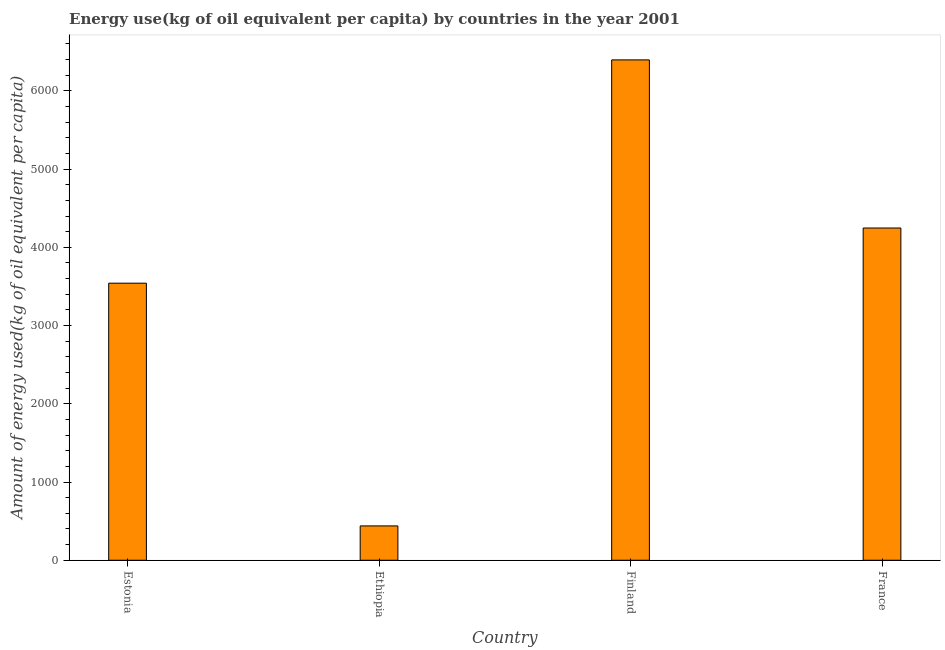Does the graph contain grids?
Your response must be concise. No. What is the title of the graph?
Offer a terse response. Energy use(kg of oil equivalent per capita) by countries in the year 2001. What is the label or title of the Y-axis?
Your answer should be compact. Amount of energy used(kg of oil equivalent per capita). What is the amount of energy used in Ethiopia?
Make the answer very short. 438.96. Across all countries, what is the maximum amount of energy used?
Your response must be concise. 6395.27. Across all countries, what is the minimum amount of energy used?
Give a very brief answer. 438.96. In which country was the amount of energy used minimum?
Make the answer very short. Ethiopia. What is the sum of the amount of energy used?
Provide a succinct answer. 1.46e+04. What is the difference between the amount of energy used in Ethiopia and Finland?
Offer a terse response. -5956.32. What is the average amount of energy used per country?
Keep it short and to the point. 3655.57. What is the median amount of energy used?
Make the answer very short. 3894.02. What is the ratio of the amount of energy used in Estonia to that in France?
Your response must be concise. 0.83. Is the difference between the amount of energy used in Estonia and Finland greater than the difference between any two countries?
Your answer should be very brief. No. What is the difference between the highest and the second highest amount of energy used?
Your response must be concise. 2148.76. Is the sum of the amount of energy used in Ethiopia and France greater than the maximum amount of energy used across all countries?
Your answer should be very brief. No. What is the difference between the highest and the lowest amount of energy used?
Offer a very short reply. 5956.32. How many bars are there?
Give a very brief answer. 4. Are all the bars in the graph horizontal?
Make the answer very short. No. What is the Amount of energy used(kg of oil equivalent per capita) of Estonia?
Your answer should be very brief. 3541.51. What is the Amount of energy used(kg of oil equivalent per capita) of Ethiopia?
Keep it short and to the point. 438.96. What is the Amount of energy used(kg of oil equivalent per capita) of Finland?
Give a very brief answer. 6395.27. What is the Amount of energy used(kg of oil equivalent per capita) of France?
Offer a terse response. 4246.52. What is the difference between the Amount of energy used(kg of oil equivalent per capita) in Estonia and Ethiopia?
Ensure brevity in your answer.  3102.55. What is the difference between the Amount of energy used(kg of oil equivalent per capita) in Estonia and Finland?
Make the answer very short. -2853.76. What is the difference between the Amount of energy used(kg of oil equivalent per capita) in Estonia and France?
Offer a very short reply. -705.01. What is the difference between the Amount of energy used(kg of oil equivalent per capita) in Ethiopia and Finland?
Offer a very short reply. -5956.32. What is the difference between the Amount of energy used(kg of oil equivalent per capita) in Ethiopia and France?
Provide a short and direct response. -3807.56. What is the difference between the Amount of energy used(kg of oil equivalent per capita) in Finland and France?
Your answer should be very brief. 2148.76. What is the ratio of the Amount of energy used(kg of oil equivalent per capita) in Estonia to that in Ethiopia?
Make the answer very short. 8.07. What is the ratio of the Amount of energy used(kg of oil equivalent per capita) in Estonia to that in Finland?
Ensure brevity in your answer.  0.55. What is the ratio of the Amount of energy used(kg of oil equivalent per capita) in Estonia to that in France?
Provide a short and direct response. 0.83. What is the ratio of the Amount of energy used(kg of oil equivalent per capita) in Ethiopia to that in Finland?
Give a very brief answer. 0.07. What is the ratio of the Amount of energy used(kg of oil equivalent per capita) in Ethiopia to that in France?
Ensure brevity in your answer.  0.1. What is the ratio of the Amount of energy used(kg of oil equivalent per capita) in Finland to that in France?
Your response must be concise. 1.51. 